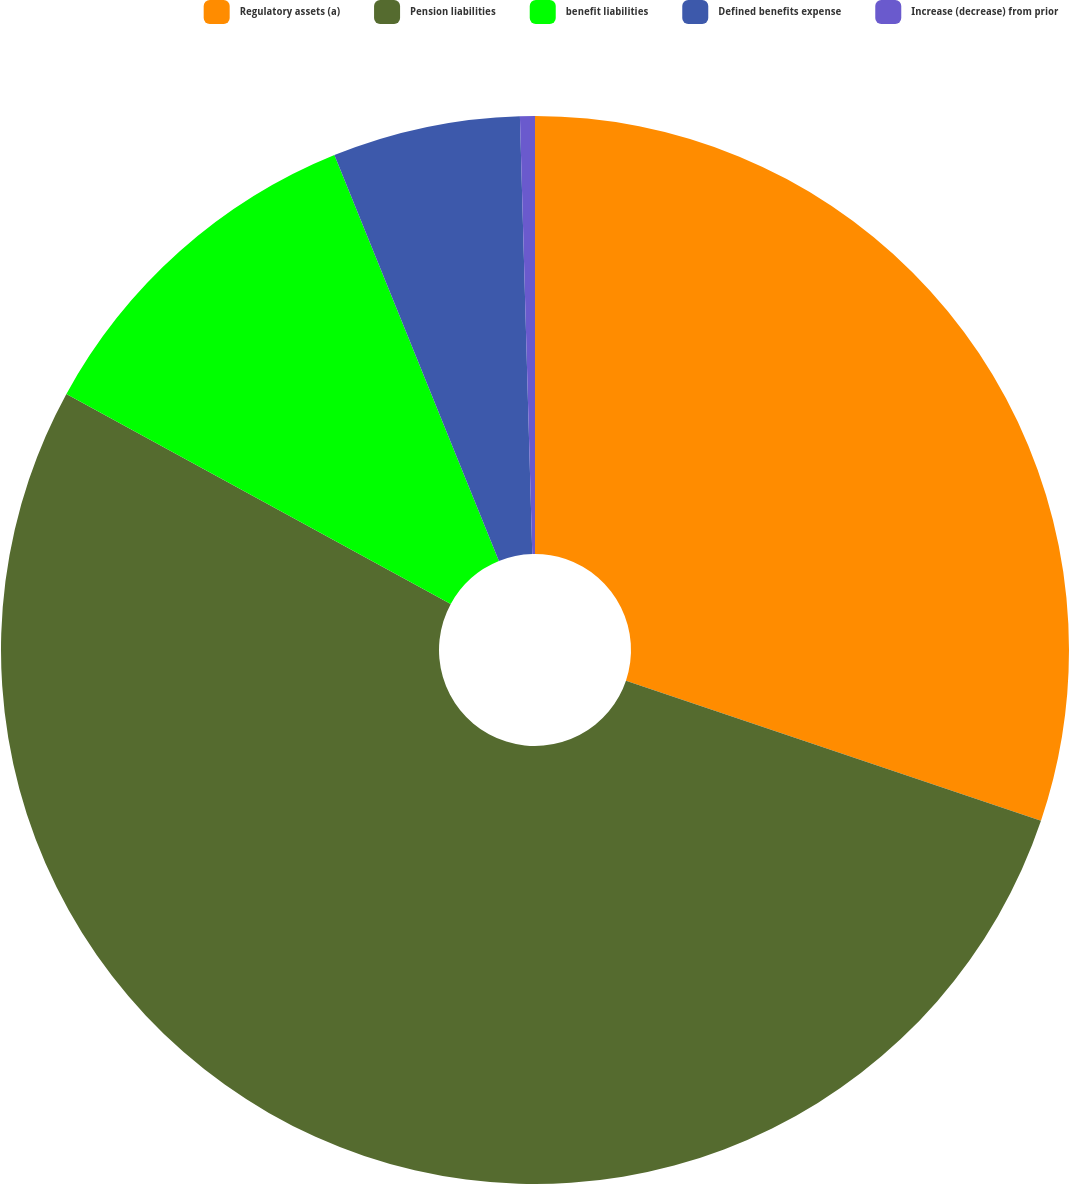Convert chart to OTSL. <chart><loc_0><loc_0><loc_500><loc_500><pie_chart><fcel>Regulatory assets (a)<fcel>Pension liabilities<fcel>benefit liabilities<fcel>Defined benefits expense<fcel>Increase (decrease) from prior<nl><fcel>30.18%<fcel>52.78%<fcel>10.91%<fcel>5.68%<fcel>0.45%<nl></chart> 